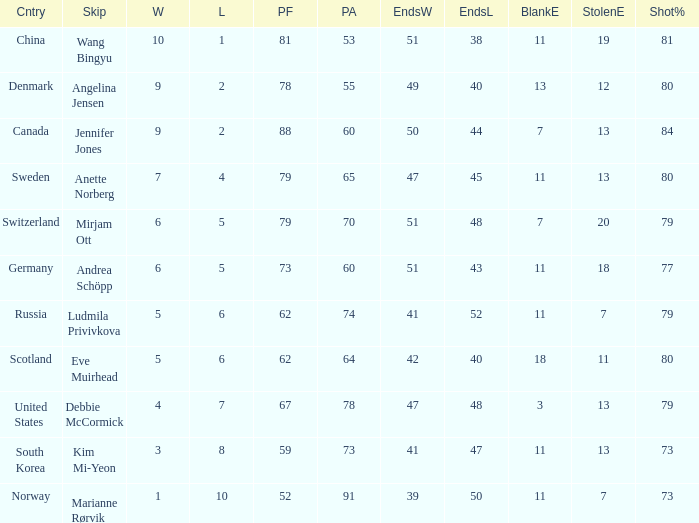What is the minimum Wins a team has? 1.0. 